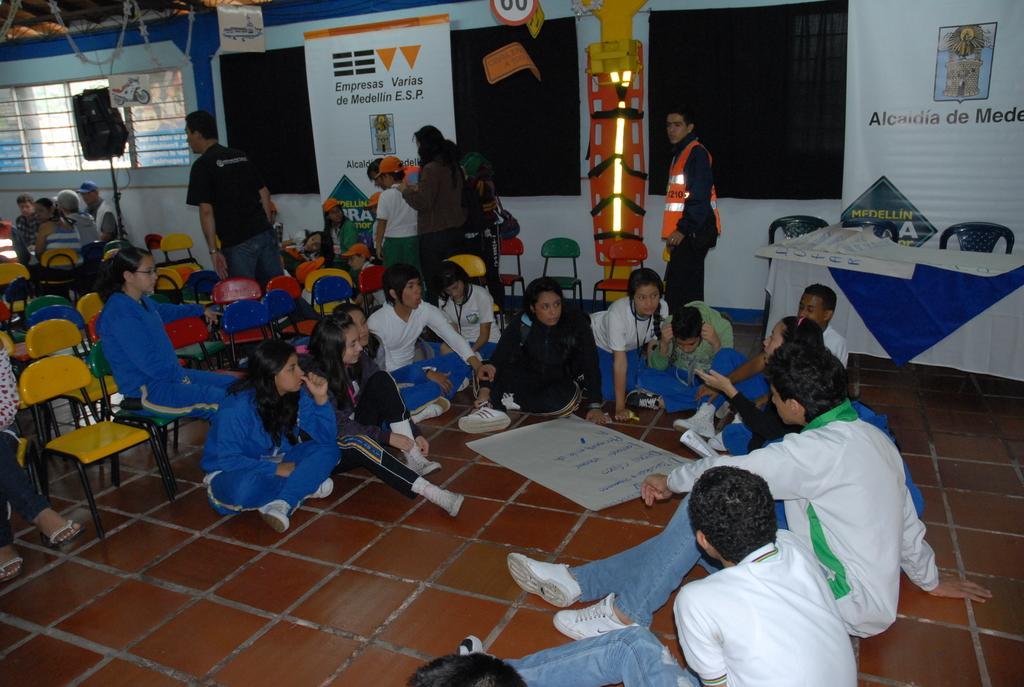Could you give a brief overview of what you see in this image? This image is clicked in a room. There are so many persons in this image. There are chairs on the left side. There are people sitting on the right side. There is a chart in the bottom. There are windows on the left side. 